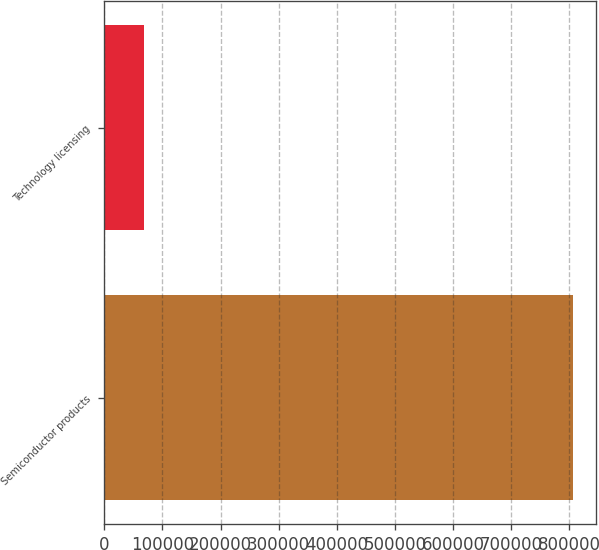<chart> <loc_0><loc_0><loc_500><loc_500><bar_chart><fcel>Semiconductor products<fcel>Technology licensing<nl><fcel>806398<fcel>68038<nl></chart> 